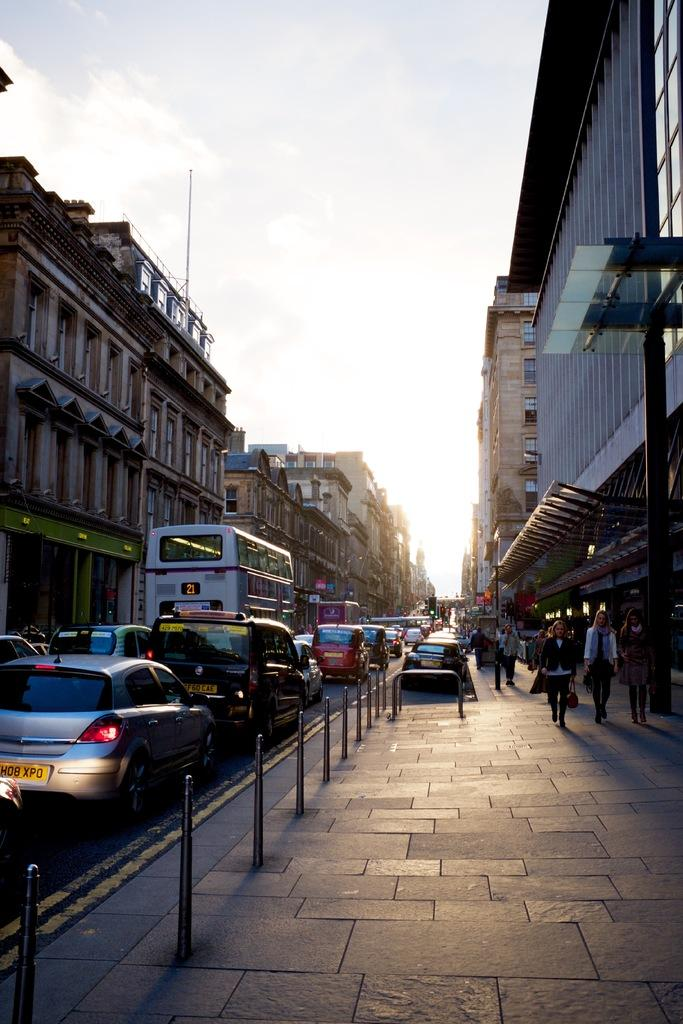<image>
Offer a succinct explanation of the picture presented. A congested street and a car with a yellow license plate HD8 XPD 